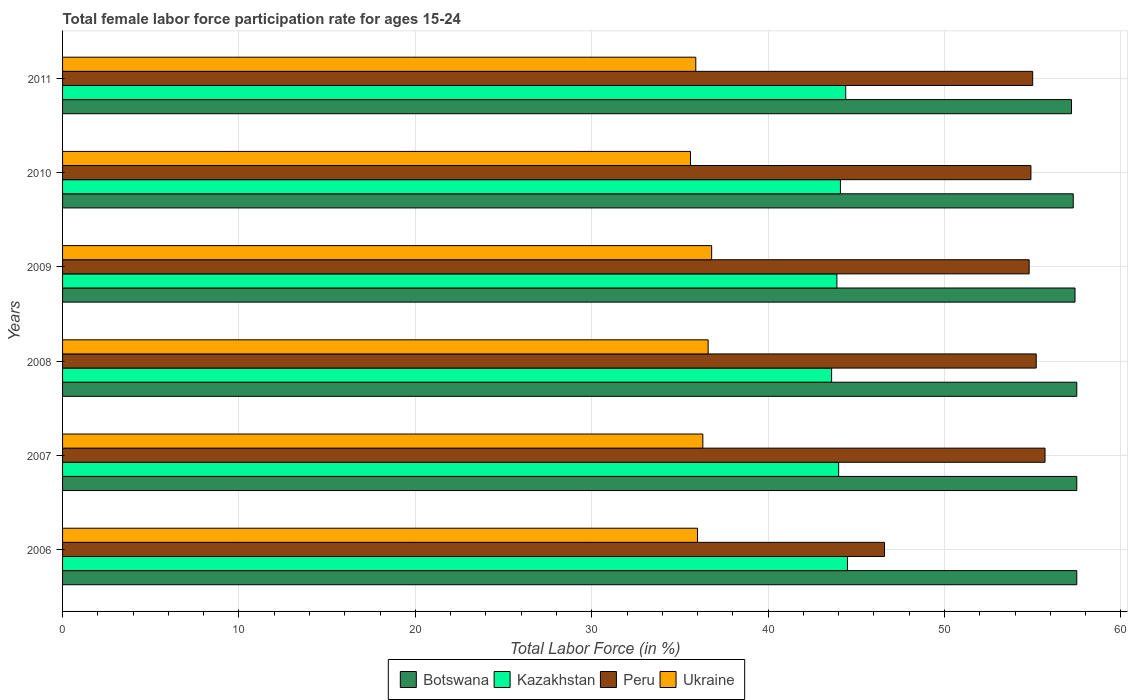How many different coloured bars are there?
Give a very brief answer. 4. How many groups of bars are there?
Ensure brevity in your answer.  6. How many bars are there on the 6th tick from the top?
Offer a terse response. 4. How many bars are there on the 6th tick from the bottom?
Keep it short and to the point. 4. What is the label of the 3rd group of bars from the top?
Your response must be concise. 2009. What is the female labor force participation rate in Peru in 2008?
Your answer should be compact. 55.2. Across all years, what is the maximum female labor force participation rate in Kazakhstan?
Your response must be concise. 44.5. Across all years, what is the minimum female labor force participation rate in Peru?
Make the answer very short. 46.6. In which year was the female labor force participation rate in Ukraine maximum?
Make the answer very short. 2009. In which year was the female labor force participation rate in Ukraine minimum?
Ensure brevity in your answer.  2010. What is the total female labor force participation rate in Ukraine in the graph?
Provide a succinct answer. 217.2. What is the difference between the female labor force participation rate in Ukraine in 2006 and that in 2011?
Ensure brevity in your answer.  0.1. What is the difference between the female labor force participation rate in Kazakhstan in 2010 and the female labor force participation rate in Peru in 2008?
Keep it short and to the point. -11.1. What is the average female labor force participation rate in Ukraine per year?
Your answer should be very brief. 36.2. In the year 2010, what is the difference between the female labor force participation rate in Botswana and female labor force participation rate in Kazakhstan?
Your response must be concise. 13.2. What is the ratio of the female labor force participation rate in Botswana in 2008 to that in 2011?
Your answer should be compact. 1.01. What is the difference between the highest and the lowest female labor force participation rate in Peru?
Offer a terse response. 9.1. Is the sum of the female labor force participation rate in Kazakhstan in 2008 and 2009 greater than the maximum female labor force participation rate in Botswana across all years?
Offer a very short reply. Yes. Is it the case that in every year, the sum of the female labor force participation rate in Kazakhstan and female labor force participation rate in Ukraine is greater than the sum of female labor force participation rate in Peru and female labor force participation rate in Botswana?
Provide a short and direct response. No. What does the 3rd bar from the top in 2007 represents?
Give a very brief answer. Kazakhstan. What does the 4th bar from the bottom in 2008 represents?
Make the answer very short. Ukraine. How many bars are there?
Give a very brief answer. 24. Are all the bars in the graph horizontal?
Give a very brief answer. Yes. How many years are there in the graph?
Offer a terse response. 6. What is the difference between two consecutive major ticks on the X-axis?
Ensure brevity in your answer.  10. Are the values on the major ticks of X-axis written in scientific E-notation?
Make the answer very short. No. Does the graph contain any zero values?
Provide a succinct answer. No. Does the graph contain grids?
Your answer should be very brief. Yes. Where does the legend appear in the graph?
Provide a short and direct response. Bottom center. How many legend labels are there?
Ensure brevity in your answer.  4. What is the title of the graph?
Your response must be concise. Total female labor force participation rate for ages 15-24. What is the label or title of the Y-axis?
Provide a succinct answer. Years. What is the Total Labor Force (in %) in Botswana in 2006?
Your response must be concise. 57.5. What is the Total Labor Force (in %) of Kazakhstan in 2006?
Give a very brief answer. 44.5. What is the Total Labor Force (in %) of Peru in 2006?
Give a very brief answer. 46.6. What is the Total Labor Force (in %) of Botswana in 2007?
Ensure brevity in your answer.  57.5. What is the Total Labor Force (in %) of Peru in 2007?
Make the answer very short. 55.7. What is the Total Labor Force (in %) in Ukraine in 2007?
Provide a succinct answer. 36.3. What is the Total Labor Force (in %) in Botswana in 2008?
Your answer should be compact. 57.5. What is the Total Labor Force (in %) in Kazakhstan in 2008?
Keep it short and to the point. 43.6. What is the Total Labor Force (in %) in Peru in 2008?
Offer a very short reply. 55.2. What is the Total Labor Force (in %) of Ukraine in 2008?
Your response must be concise. 36.6. What is the Total Labor Force (in %) in Botswana in 2009?
Ensure brevity in your answer.  57.4. What is the Total Labor Force (in %) in Kazakhstan in 2009?
Your answer should be very brief. 43.9. What is the Total Labor Force (in %) of Peru in 2009?
Offer a terse response. 54.8. What is the Total Labor Force (in %) of Ukraine in 2009?
Offer a terse response. 36.8. What is the Total Labor Force (in %) of Botswana in 2010?
Make the answer very short. 57.3. What is the Total Labor Force (in %) in Kazakhstan in 2010?
Provide a short and direct response. 44.1. What is the Total Labor Force (in %) in Peru in 2010?
Your answer should be very brief. 54.9. What is the Total Labor Force (in %) in Ukraine in 2010?
Make the answer very short. 35.6. What is the Total Labor Force (in %) of Botswana in 2011?
Ensure brevity in your answer.  57.2. What is the Total Labor Force (in %) in Kazakhstan in 2011?
Your answer should be compact. 44.4. What is the Total Labor Force (in %) in Ukraine in 2011?
Your answer should be compact. 35.9. Across all years, what is the maximum Total Labor Force (in %) of Botswana?
Give a very brief answer. 57.5. Across all years, what is the maximum Total Labor Force (in %) in Kazakhstan?
Provide a succinct answer. 44.5. Across all years, what is the maximum Total Labor Force (in %) in Peru?
Give a very brief answer. 55.7. Across all years, what is the maximum Total Labor Force (in %) in Ukraine?
Give a very brief answer. 36.8. Across all years, what is the minimum Total Labor Force (in %) in Botswana?
Offer a very short reply. 57.2. Across all years, what is the minimum Total Labor Force (in %) of Kazakhstan?
Ensure brevity in your answer.  43.6. Across all years, what is the minimum Total Labor Force (in %) in Peru?
Give a very brief answer. 46.6. Across all years, what is the minimum Total Labor Force (in %) in Ukraine?
Your response must be concise. 35.6. What is the total Total Labor Force (in %) in Botswana in the graph?
Your response must be concise. 344.4. What is the total Total Labor Force (in %) in Kazakhstan in the graph?
Offer a terse response. 264.5. What is the total Total Labor Force (in %) of Peru in the graph?
Offer a very short reply. 322.2. What is the total Total Labor Force (in %) of Ukraine in the graph?
Give a very brief answer. 217.2. What is the difference between the Total Labor Force (in %) of Botswana in 2006 and that in 2007?
Ensure brevity in your answer.  0. What is the difference between the Total Labor Force (in %) in Kazakhstan in 2006 and that in 2007?
Your answer should be very brief. 0.5. What is the difference between the Total Labor Force (in %) in Peru in 2006 and that in 2007?
Give a very brief answer. -9.1. What is the difference between the Total Labor Force (in %) in Kazakhstan in 2006 and that in 2008?
Your answer should be very brief. 0.9. What is the difference between the Total Labor Force (in %) of Peru in 2006 and that in 2008?
Provide a succinct answer. -8.6. What is the difference between the Total Labor Force (in %) in Botswana in 2006 and that in 2009?
Offer a terse response. 0.1. What is the difference between the Total Labor Force (in %) of Kazakhstan in 2006 and that in 2010?
Your answer should be very brief. 0.4. What is the difference between the Total Labor Force (in %) of Ukraine in 2006 and that in 2010?
Your answer should be very brief. 0.4. What is the difference between the Total Labor Force (in %) of Peru in 2006 and that in 2011?
Your answer should be compact. -8.4. What is the difference between the Total Labor Force (in %) in Botswana in 2007 and that in 2008?
Provide a succinct answer. 0. What is the difference between the Total Labor Force (in %) in Ukraine in 2007 and that in 2008?
Your response must be concise. -0.3. What is the difference between the Total Labor Force (in %) in Peru in 2007 and that in 2009?
Your answer should be compact. 0.9. What is the difference between the Total Labor Force (in %) in Ukraine in 2007 and that in 2009?
Offer a terse response. -0.5. What is the difference between the Total Labor Force (in %) of Botswana in 2007 and that in 2010?
Provide a short and direct response. 0.2. What is the difference between the Total Labor Force (in %) in Peru in 2007 and that in 2010?
Keep it short and to the point. 0.8. What is the difference between the Total Labor Force (in %) in Peru in 2007 and that in 2011?
Make the answer very short. 0.7. What is the difference between the Total Labor Force (in %) of Peru in 2008 and that in 2009?
Provide a succinct answer. 0.4. What is the difference between the Total Labor Force (in %) of Kazakhstan in 2008 and that in 2010?
Your answer should be compact. -0.5. What is the difference between the Total Labor Force (in %) of Peru in 2008 and that in 2010?
Give a very brief answer. 0.3. What is the difference between the Total Labor Force (in %) in Botswana in 2008 and that in 2011?
Your answer should be very brief. 0.3. What is the difference between the Total Labor Force (in %) in Kazakhstan in 2008 and that in 2011?
Your answer should be very brief. -0.8. What is the difference between the Total Labor Force (in %) of Peru in 2008 and that in 2011?
Make the answer very short. 0.2. What is the difference between the Total Labor Force (in %) in Peru in 2009 and that in 2010?
Make the answer very short. -0.1. What is the difference between the Total Labor Force (in %) of Ukraine in 2009 and that in 2010?
Offer a terse response. 1.2. What is the difference between the Total Labor Force (in %) of Peru in 2009 and that in 2011?
Keep it short and to the point. -0.2. What is the difference between the Total Labor Force (in %) in Kazakhstan in 2010 and that in 2011?
Make the answer very short. -0.3. What is the difference between the Total Labor Force (in %) in Peru in 2010 and that in 2011?
Your answer should be compact. -0.1. What is the difference between the Total Labor Force (in %) in Ukraine in 2010 and that in 2011?
Your answer should be compact. -0.3. What is the difference between the Total Labor Force (in %) of Botswana in 2006 and the Total Labor Force (in %) of Ukraine in 2007?
Offer a very short reply. 21.2. What is the difference between the Total Labor Force (in %) in Botswana in 2006 and the Total Labor Force (in %) in Kazakhstan in 2008?
Your response must be concise. 13.9. What is the difference between the Total Labor Force (in %) of Botswana in 2006 and the Total Labor Force (in %) of Peru in 2008?
Make the answer very short. 2.3. What is the difference between the Total Labor Force (in %) in Botswana in 2006 and the Total Labor Force (in %) in Ukraine in 2008?
Your response must be concise. 20.9. What is the difference between the Total Labor Force (in %) of Peru in 2006 and the Total Labor Force (in %) of Ukraine in 2008?
Offer a very short reply. 10. What is the difference between the Total Labor Force (in %) in Botswana in 2006 and the Total Labor Force (in %) in Peru in 2009?
Offer a terse response. 2.7. What is the difference between the Total Labor Force (in %) of Botswana in 2006 and the Total Labor Force (in %) of Ukraine in 2009?
Make the answer very short. 20.7. What is the difference between the Total Labor Force (in %) of Kazakhstan in 2006 and the Total Labor Force (in %) of Peru in 2009?
Provide a succinct answer. -10.3. What is the difference between the Total Labor Force (in %) of Kazakhstan in 2006 and the Total Labor Force (in %) of Ukraine in 2009?
Provide a succinct answer. 7.7. What is the difference between the Total Labor Force (in %) of Botswana in 2006 and the Total Labor Force (in %) of Kazakhstan in 2010?
Offer a terse response. 13.4. What is the difference between the Total Labor Force (in %) in Botswana in 2006 and the Total Labor Force (in %) in Peru in 2010?
Keep it short and to the point. 2.6. What is the difference between the Total Labor Force (in %) in Botswana in 2006 and the Total Labor Force (in %) in Ukraine in 2010?
Offer a terse response. 21.9. What is the difference between the Total Labor Force (in %) in Botswana in 2006 and the Total Labor Force (in %) in Peru in 2011?
Offer a terse response. 2.5. What is the difference between the Total Labor Force (in %) in Botswana in 2006 and the Total Labor Force (in %) in Ukraine in 2011?
Provide a succinct answer. 21.6. What is the difference between the Total Labor Force (in %) of Kazakhstan in 2006 and the Total Labor Force (in %) of Peru in 2011?
Keep it short and to the point. -10.5. What is the difference between the Total Labor Force (in %) of Peru in 2006 and the Total Labor Force (in %) of Ukraine in 2011?
Keep it short and to the point. 10.7. What is the difference between the Total Labor Force (in %) in Botswana in 2007 and the Total Labor Force (in %) in Peru in 2008?
Your response must be concise. 2.3. What is the difference between the Total Labor Force (in %) in Botswana in 2007 and the Total Labor Force (in %) in Ukraine in 2008?
Give a very brief answer. 20.9. What is the difference between the Total Labor Force (in %) in Kazakhstan in 2007 and the Total Labor Force (in %) in Peru in 2008?
Give a very brief answer. -11.2. What is the difference between the Total Labor Force (in %) of Botswana in 2007 and the Total Labor Force (in %) of Kazakhstan in 2009?
Ensure brevity in your answer.  13.6. What is the difference between the Total Labor Force (in %) in Botswana in 2007 and the Total Labor Force (in %) in Ukraine in 2009?
Make the answer very short. 20.7. What is the difference between the Total Labor Force (in %) in Kazakhstan in 2007 and the Total Labor Force (in %) in Ukraine in 2009?
Offer a terse response. 7.2. What is the difference between the Total Labor Force (in %) of Peru in 2007 and the Total Labor Force (in %) of Ukraine in 2009?
Make the answer very short. 18.9. What is the difference between the Total Labor Force (in %) of Botswana in 2007 and the Total Labor Force (in %) of Ukraine in 2010?
Your response must be concise. 21.9. What is the difference between the Total Labor Force (in %) of Peru in 2007 and the Total Labor Force (in %) of Ukraine in 2010?
Your response must be concise. 20.1. What is the difference between the Total Labor Force (in %) in Botswana in 2007 and the Total Labor Force (in %) in Kazakhstan in 2011?
Keep it short and to the point. 13.1. What is the difference between the Total Labor Force (in %) of Botswana in 2007 and the Total Labor Force (in %) of Peru in 2011?
Ensure brevity in your answer.  2.5. What is the difference between the Total Labor Force (in %) of Botswana in 2007 and the Total Labor Force (in %) of Ukraine in 2011?
Keep it short and to the point. 21.6. What is the difference between the Total Labor Force (in %) in Kazakhstan in 2007 and the Total Labor Force (in %) in Ukraine in 2011?
Make the answer very short. 8.1. What is the difference between the Total Labor Force (in %) of Peru in 2007 and the Total Labor Force (in %) of Ukraine in 2011?
Your answer should be very brief. 19.8. What is the difference between the Total Labor Force (in %) of Botswana in 2008 and the Total Labor Force (in %) of Peru in 2009?
Keep it short and to the point. 2.7. What is the difference between the Total Labor Force (in %) of Botswana in 2008 and the Total Labor Force (in %) of Ukraine in 2009?
Your answer should be very brief. 20.7. What is the difference between the Total Labor Force (in %) in Kazakhstan in 2008 and the Total Labor Force (in %) in Peru in 2009?
Your response must be concise. -11.2. What is the difference between the Total Labor Force (in %) in Kazakhstan in 2008 and the Total Labor Force (in %) in Ukraine in 2009?
Your answer should be very brief. 6.8. What is the difference between the Total Labor Force (in %) of Botswana in 2008 and the Total Labor Force (in %) of Kazakhstan in 2010?
Give a very brief answer. 13.4. What is the difference between the Total Labor Force (in %) of Botswana in 2008 and the Total Labor Force (in %) of Peru in 2010?
Your answer should be compact. 2.6. What is the difference between the Total Labor Force (in %) of Botswana in 2008 and the Total Labor Force (in %) of Ukraine in 2010?
Keep it short and to the point. 21.9. What is the difference between the Total Labor Force (in %) in Kazakhstan in 2008 and the Total Labor Force (in %) in Peru in 2010?
Your answer should be compact. -11.3. What is the difference between the Total Labor Force (in %) in Peru in 2008 and the Total Labor Force (in %) in Ukraine in 2010?
Keep it short and to the point. 19.6. What is the difference between the Total Labor Force (in %) in Botswana in 2008 and the Total Labor Force (in %) in Ukraine in 2011?
Your answer should be compact. 21.6. What is the difference between the Total Labor Force (in %) in Kazakhstan in 2008 and the Total Labor Force (in %) in Peru in 2011?
Give a very brief answer. -11.4. What is the difference between the Total Labor Force (in %) in Peru in 2008 and the Total Labor Force (in %) in Ukraine in 2011?
Offer a very short reply. 19.3. What is the difference between the Total Labor Force (in %) in Botswana in 2009 and the Total Labor Force (in %) in Kazakhstan in 2010?
Make the answer very short. 13.3. What is the difference between the Total Labor Force (in %) of Botswana in 2009 and the Total Labor Force (in %) of Peru in 2010?
Your answer should be compact. 2.5. What is the difference between the Total Labor Force (in %) in Botswana in 2009 and the Total Labor Force (in %) in Ukraine in 2010?
Ensure brevity in your answer.  21.8. What is the difference between the Total Labor Force (in %) in Kazakhstan in 2009 and the Total Labor Force (in %) in Ukraine in 2010?
Your answer should be very brief. 8.3. What is the difference between the Total Labor Force (in %) in Peru in 2009 and the Total Labor Force (in %) in Ukraine in 2010?
Your answer should be compact. 19.2. What is the difference between the Total Labor Force (in %) in Botswana in 2009 and the Total Labor Force (in %) in Kazakhstan in 2011?
Give a very brief answer. 13. What is the difference between the Total Labor Force (in %) in Kazakhstan in 2009 and the Total Labor Force (in %) in Ukraine in 2011?
Give a very brief answer. 8. What is the difference between the Total Labor Force (in %) of Botswana in 2010 and the Total Labor Force (in %) of Ukraine in 2011?
Provide a short and direct response. 21.4. What is the difference between the Total Labor Force (in %) in Kazakhstan in 2010 and the Total Labor Force (in %) in Ukraine in 2011?
Your answer should be very brief. 8.2. What is the difference between the Total Labor Force (in %) in Peru in 2010 and the Total Labor Force (in %) in Ukraine in 2011?
Offer a terse response. 19. What is the average Total Labor Force (in %) of Botswana per year?
Your answer should be compact. 57.4. What is the average Total Labor Force (in %) of Kazakhstan per year?
Your answer should be compact. 44.08. What is the average Total Labor Force (in %) in Peru per year?
Ensure brevity in your answer.  53.7. What is the average Total Labor Force (in %) of Ukraine per year?
Offer a very short reply. 36.2. In the year 2006, what is the difference between the Total Labor Force (in %) in Botswana and Total Labor Force (in %) in Kazakhstan?
Offer a very short reply. 13. In the year 2006, what is the difference between the Total Labor Force (in %) of Kazakhstan and Total Labor Force (in %) of Peru?
Offer a terse response. -2.1. In the year 2006, what is the difference between the Total Labor Force (in %) in Kazakhstan and Total Labor Force (in %) in Ukraine?
Make the answer very short. 8.5. In the year 2007, what is the difference between the Total Labor Force (in %) of Botswana and Total Labor Force (in %) of Kazakhstan?
Offer a terse response. 13.5. In the year 2007, what is the difference between the Total Labor Force (in %) in Botswana and Total Labor Force (in %) in Ukraine?
Offer a terse response. 21.2. In the year 2007, what is the difference between the Total Labor Force (in %) of Kazakhstan and Total Labor Force (in %) of Peru?
Provide a succinct answer. -11.7. In the year 2008, what is the difference between the Total Labor Force (in %) of Botswana and Total Labor Force (in %) of Peru?
Offer a very short reply. 2.3. In the year 2008, what is the difference between the Total Labor Force (in %) of Botswana and Total Labor Force (in %) of Ukraine?
Your response must be concise. 20.9. In the year 2008, what is the difference between the Total Labor Force (in %) in Peru and Total Labor Force (in %) in Ukraine?
Ensure brevity in your answer.  18.6. In the year 2009, what is the difference between the Total Labor Force (in %) of Botswana and Total Labor Force (in %) of Peru?
Give a very brief answer. 2.6. In the year 2009, what is the difference between the Total Labor Force (in %) in Botswana and Total Labor Force (in %) in Ukraine?
Keep it short and to the point. 20.6. In the year 2009, what is the difference between the Total Labor Force (in %) of Peru and Total Labor Force (in %) of Ukraine?
Provide a succinct answer. 18. In the year 2010, what is the difference between the Total Labor Force (in %) in Botswana and Total Labor Force (in %) in Kazakhstan?
Make the answer very short. 13.2. In the year 2010, what is the difference between the Total Labor Force (in %) in Botswana and Total Labor Force (in %) in Peru?
Your answer should be very brief. 2.4. In the year 2010, what is the difference between the Total Labor Force (in %) of Botswana and Total Labor Force (in %) of Ukraine?
Your answer should be very brief. 21.7. In the year 2010, what is the difference between the Total Labor Force (in %) of Peru and Total Labor Force (in %) of Ukraine?
Your answer should be very brief. 19.3. In the year 2011, what is the difference between the Total Labor Force (in %) of Botswana and Total Labor Force (in %) of Peru?
Provide a short and direct response. 2.2. In the year 2011, what is the difference between the Total Labor Force (in %) of Botswana and Total Labor Force (in %) of Ukraine?
Offer a very short reply. 21.3. In the year 2011, what is the difference between the Total Labor Force (in %) of Kazakhstan and Total Labor Force (in %) of Peru?
Provide a succinct answer. -10.6. In the year 2011, what is the difference between the Total Labor Force (in %) in Kazakhstan and Total Labor Force (in %) in Ukraine?
Provide a short and direct response. 8.5. What is the ratio of the Total Labor Force (in %) in Kazakhstan in 2006 to that in 2007?
Your answer should be compact. 1.01. What is the ratio of the Total Labor Force (in %) in Peru in 2006 to that in 2007?
Offer a very short reply. 0.84. What is the ratio of the Total Labor Force (in %) in Kazakhstan in 2006 to that in 2008?
Keep it short and to the point. 1.02. What is the ratio of the Total Labor Force (in %) of Peru in 2006 to that in 2008?
Ensure brevity in your answer.  0.84. What is the ratio of the Total Labor Force (in %) of Ukraine in 2006 to that in 2008?
Your answer should be very brief. 0.98. What is the ratio of the Total Labor Force (in %) of Kazakhstan in 2006 to that in 2009?
Your answer should be very brief. 1.01. What is the ratio of the Total Labor Force (in %) of Peru in 2006 to that in 2009?
Your answer should be compact. 0.85. What is the ratio of the Total Labor Force (in %) in Ukraine in 2006 to that in 2009?
Keep it short and to the point. 0.98. What is the ratio of the Total Labor Force (in %) in Botswana in 2006 to that in 2010?
Ensure brevity in your answer.  1. What is the ratio of the Total Labor Force (in %) of Kazakhstan in 2006 to that in 2010?
Your answer should be compact. 1.01. What is the ratio of the Total Labor Force (in %) in Peru in 2006 to that in 2010?
Offer a terse response. 0.85. What is the ratio of the Total Labor Force (in %) of Ukraine in 2006 to that in 2010?
Your answer should be very brief. 1.01. What is the ratio of the Total Labor Force (in %) of Botswana in 2006 to that in 2011?
Offer a very short reply. 1.01. What is the ratio of the Total Labor Force (in %) of Kazakhstan in 2006 to that in 2011?
Your answer should be very brief. 1. What is the ratio of the Total Labor Force (in %) of Peru in 2006 to that in 2011?
Provide a short and direct response. 0.85. What is the ratio of the Total Labor Force (in %) in Ukraine in 2006 to that in 2011?
Your answer should be very brief. 1. What is the ratio of the Total Labor Force (in %) in Botswana in 2007 to that in 2008?
Your answer should be very brief. 1. What is the ratio of the Total Labor Force (in %) in Kazakhstan in 2007 to that in 2008?
Your response must be concise. 1.01. What is the ratio of the Total Labor Force (in %) of Peru in 2007 to that in 2008?
Provide a short and direct response. 1.01. What is the ratio of the Total Labor Force (in %) of Ukraine in 2007 to that in 2008?
Provide a succinct answer. 0.99. What is the ratio of the Total Labor Force (in %) of Kazakhstan in 2007 to that in 2009?
Make the answer very short. 1. What is the ratio of the Total Labor Force (in %) of Peru in 2007 to that in 2009?
Provide a short and direct response. 1.02. What is the ratio of the Total Labor Force (in %) of Ukraine in 2007 to that in 2009?
Your answer should be very brief. 0.99. What is the ratio of the Total Labor Force (in %) of Botswana in 2007 to that in 2010?
Provide a short and direct response. 1. What is the ratio of the Total Labor Force (in %) in Kazakhstan in 2007 to that in 2010?
Your response must be concise. 1. What is the ratio of the Total Labor Force (in %) of Peru in 2007 to that in 2010?
Your answer should be compact. 1.01. What is the ratio of the Total Labor Force (in %) of Ukraine in 2007 to that in 2010?
Keep it short and to the point. 1.02. What is the ratio of the Total Labor Force (in %) in Botswana in 2007 to that in 2011?
Your answer should be compact. 1.01. What is the ratio of the Total Labor Force (in %) of Kazakhstan in 2007 to that in 2011?
Your response must be concise. 0.99. What is the ratio of the Total Labor Force (in %) in Peru in 2007 to that in 2011?
Give a very brief answer. 1.01. What is the ratio of the Total Labor Force (in %) in Ukraine in 2007 to that in 2011?
Provide a short and direct response. 1.01. What is the ratio of the Total Labor Force (in %) of Botswana in 2008 to that in 2009?
Provide a short and direct response. 1. What is the ratio of the Total Labor Force (in %) in Peru in 2008 to that in 2009?
Offer a terse response. 1.01. What is the ratio of the Total Labor Force (in %) of Kazakhstan in 2008 to that in 2010?
Your answer should be compact. 0.99. What is the ratio of the Total Labor Force (in %) in Ukraine in 2008 to that in 2010?
Provide a succinct answer. 1.03. What is the ratio of the Total Labor Force (in %) in Peru in 2008 to that in 2011?
Provide a short and direct response. 1. What is the ratio of the Total Labor Force (in %) of Ukraine in 2008 to that in 2011?
Keep it short and to the point. 1.02. What is the ratio of the Total Labor Force (in %) of Botswana in 2009 to that in 2010?
Your response must be concise. 1. What is the ratio of the Total Labor Force (in %) in Ukraine in 2009 to that in 2010?
Ensure brevity in your answer.  1.03. What is the ratio of the Total Labor Force (in %) of Botswana in 2009 to that in 2011?
Keep it short and to the point. 1. What is the ratio of the Total Labor Force (in %) of Kazakhstan in 2009 to that in 2011?
Provide a short and direct response. 0.99. What is the ratio of the Total Labor Force (in %) of Peru in 2009 to that in 2011?
Provide a short and direct response. 1. What is the ratio of the Total Labor Force (in %) in Ukraine in 2009 to that in 2011?
Your response must be concise. 1.03. What is the ratio of the Total Labor Force (in %) of Botswana in 2010 to that in 2011?
Make the answer very short. 1. What is the ratio of the Total Labor Force (in %) of Kazakhstan in 2010 to that in 2011?
Your answer should be compact. 0.99. What is the ratio of the Total Labor Force (in %) of Peru in 2010 to that in 2011?
Ensure brevity in your answer.  1. What is the difference between the highest and the second highest Total Labor Force (in %) in Peru?
Keep it short and to the point. 0.5. What is the difference between the highest and the second highest Total Labor Force (in %) of Ukraine?
Ensure brevity in your answer.  0.2. 